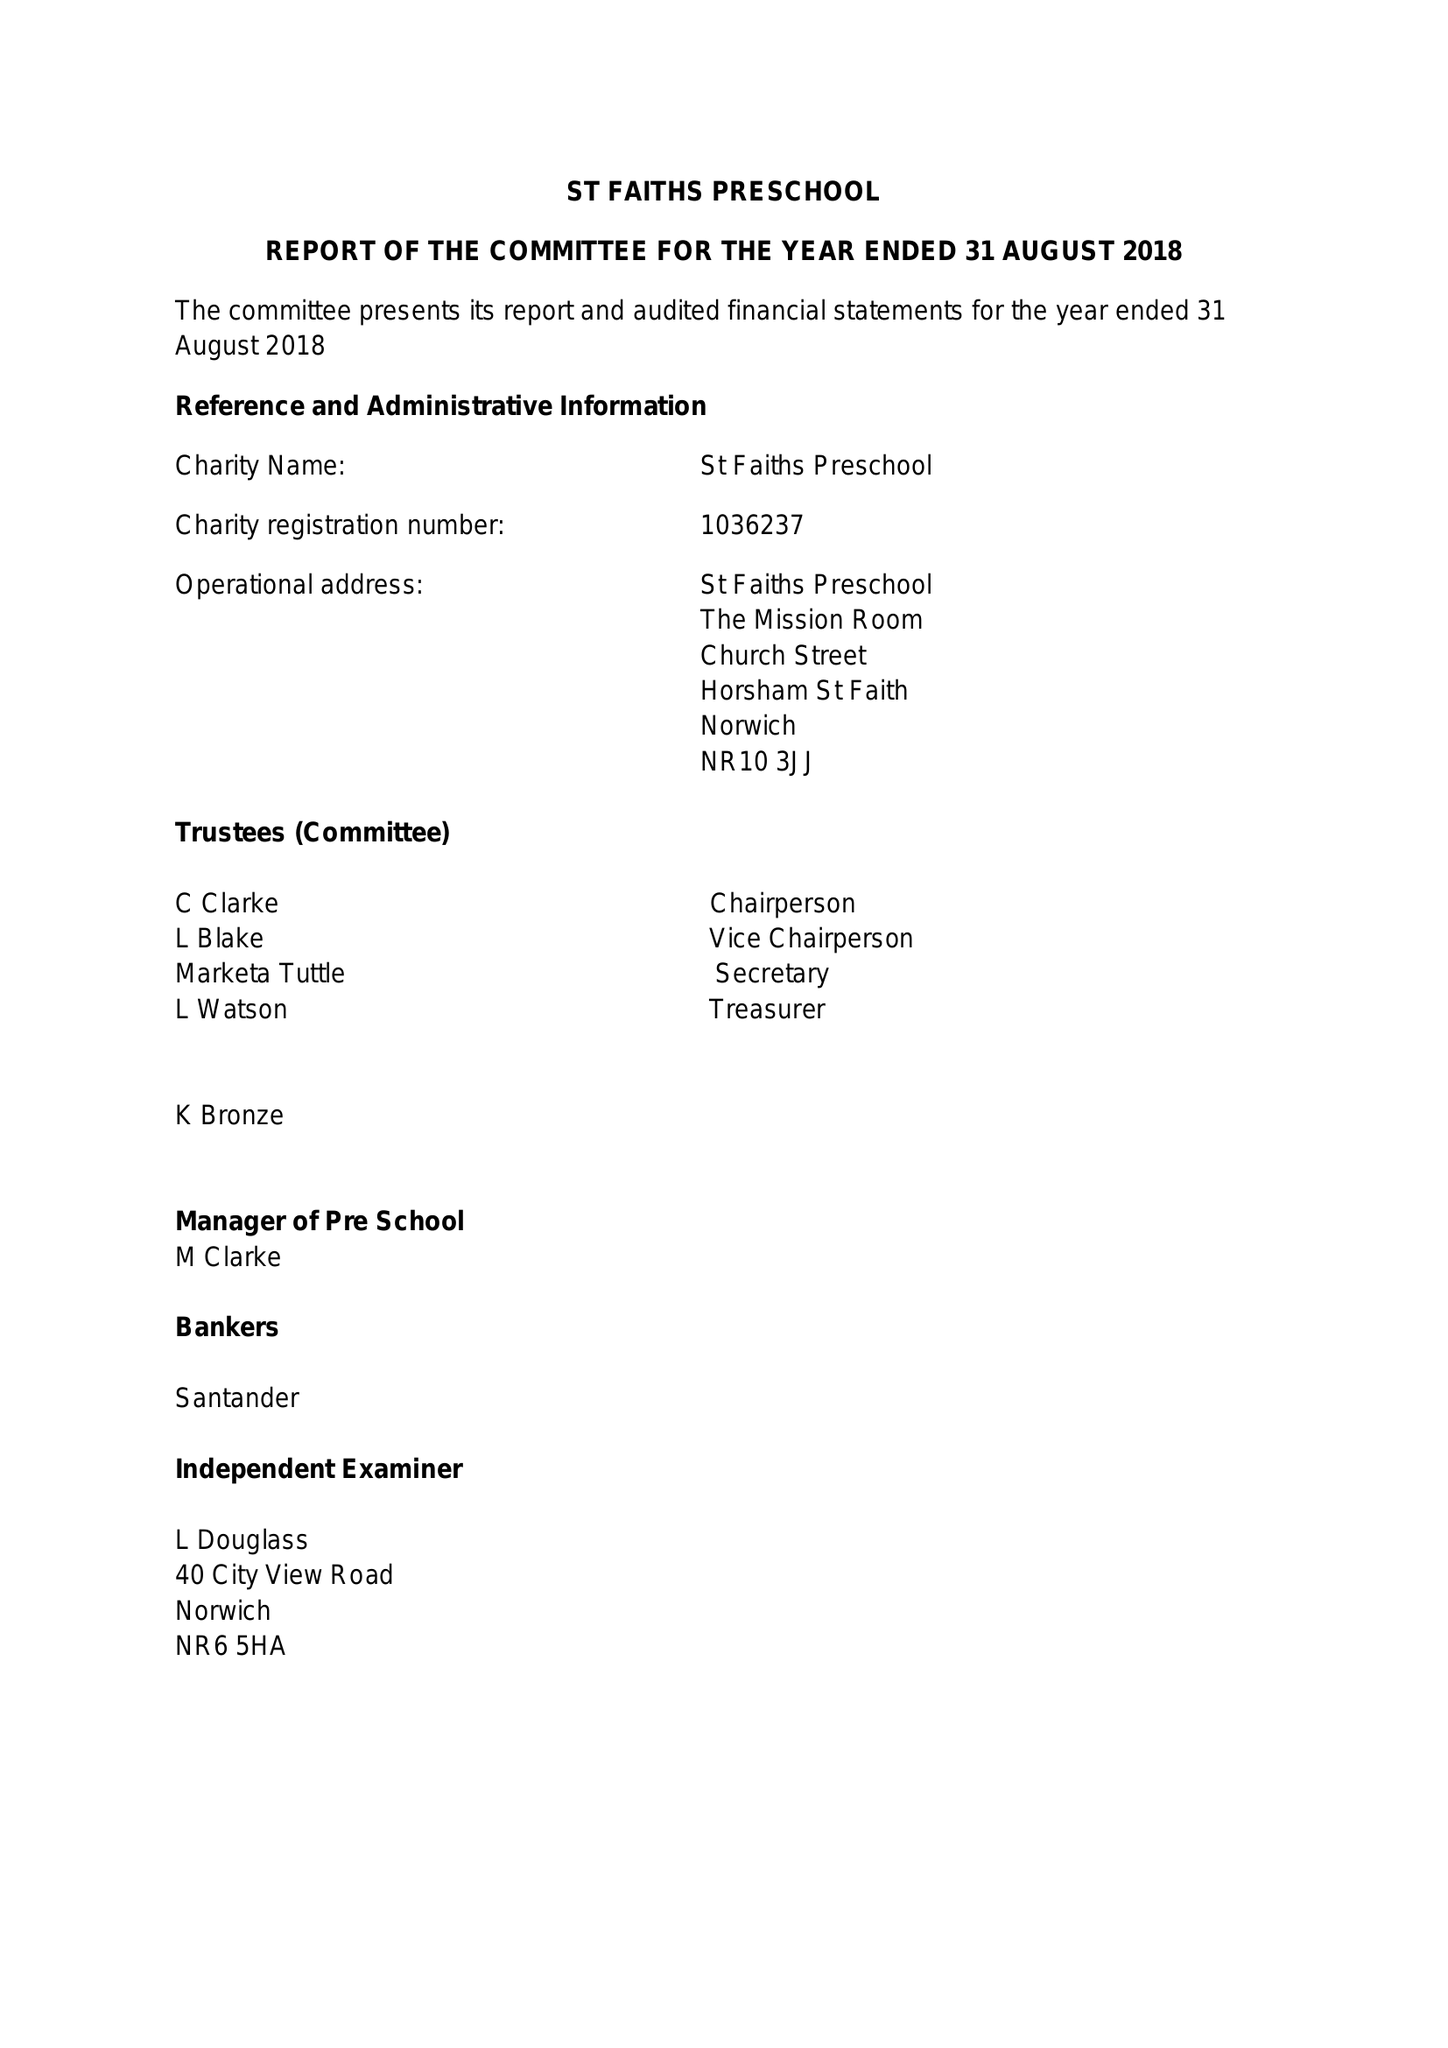What is the value for the income_annually_in_british_pounds?
Answer the question using a single word or phrase. 35983.00 